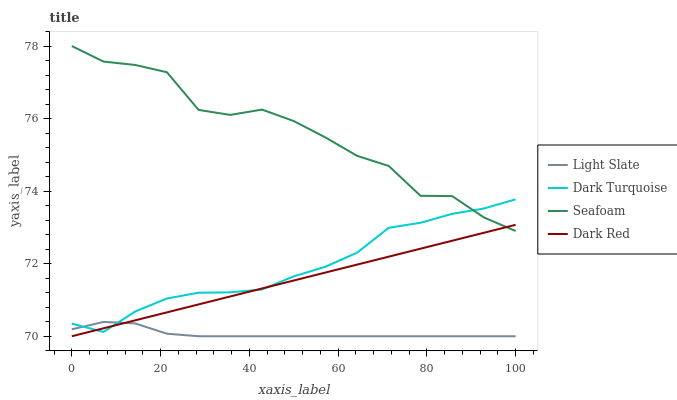Does Light Slate have the minimum area under the curve?
Answer yes or no. Yes. Does Seafoam have the maximum area under the curve?
Answer yes or no. Yes. Does Dark Turquoise have the minimum area under the curve?
Answer yes or no. No. Does Dark Turquoise have the maximum area under the curve?
Answer yes or no. No. Is Dark Red the smoothest?
Answer yes or no. Yes. Is Seafoam the roughest?
Answer yes or no. Yes. Is Dark Turquoise the smoothest?
Answer yes or no. No. Is Dark Turquoise the roughest?
Answer yes or no. No. Does Light Slate have the lowest value?
Answer yes or no. Yes. Does Dark Turquoise have the lowest value?
Answer yes or no. No. Does Seafoam have the highest value?
Answer yes or no. Yes. Does Dark Turquoise have the highest value?
Answer yes or no. No. Is Light Slate less than Seafoam?
Answer yes or no. Yes. Is Seafoam greater than Light Slate?
Answer yes or no. Yes. Does Seafoam intersect Dark Red?
Answer yes or no. Yes. Is Seafoam less than Dark Red?
Answer yes or no. No. Is Seafoam greater than Dark Red?
Answer yes or no. No. Does Light Slate intersect Seafoam?
Answer yes or no. No. 